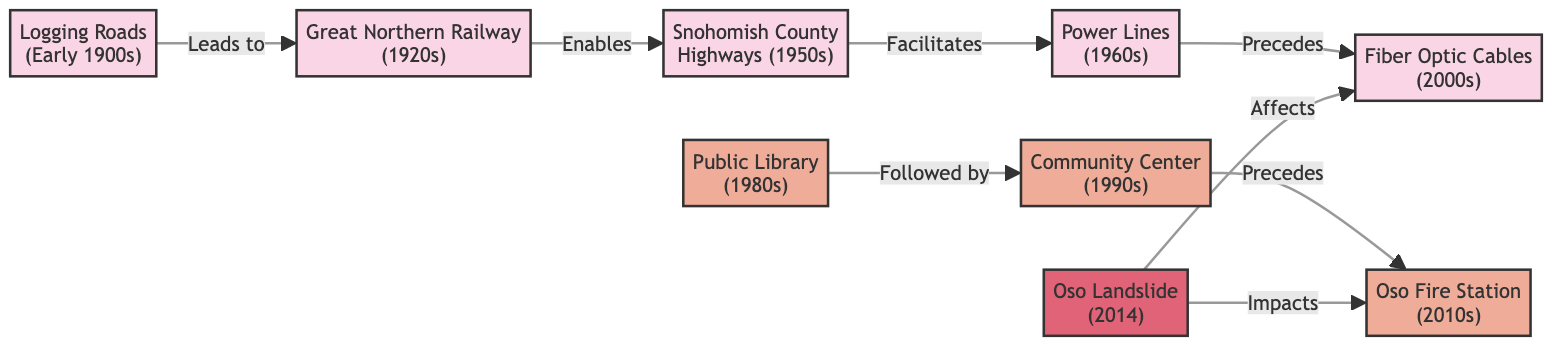What is the most recent infrastructure noted in the diagram? The nodes listed depict various infrastructure developments over time, with "Fiber Optic Cables (2000s)" being the last listed infrastructure node.
Answer: Fiber Optic Cables (2000s) How many nodes are there in total in the diagram? The diagram lists 9 nodes representing infrastructure, community, and an event. Counting these nodes gives a total of 9.
Answer: 9 What event impacts the Oso Fire Station? The relationship indicated in the diagram shows that "Oso Landslide (2014)" impacts the "Oso Fire Station (2010s)", as evidenced by the direct edge connecting them.
Answer: Oso Landslide (2014) Which infrastructure facilitated the development of Power Lines? Looking at the directed path in the diagram, "Snohomish County Highways (1950s)" is directly connected to "Power Lines (1960s)", indicating it facilitated the latter's development.
Answer: Snohomish County Highways (1950s) Which community resource follows the Public Library? The diagram shows an edge connecting "Public Library (1980s)" to "Community Center (1990s)", indicating that the Community Center followed the establishment of the Public Library.
Answer: Community Center (1990s) How many edges connect the infrastructure nodes? By counting the direct paths (edges) established among the infrastructure nodes, there are 4 edges connecting them: from Logging Roads to Great Northern Railway, then to Snohomish County Highways, followed by Power Lines, and finally to Fiber Optic Cables.
Answer: 4 What is the relationship between the Great Northern Railway and Snohomish County Highways? There is an edge that connects "Great Northern Railway (1920s)" to "Snohomish County Highways (1950s)", indicating that the former enables the latter’s development.
Answer: Enables What decade does the Community Center belong to? Through examining the node labeled "Community Center", it is associated with the 1990s, as indicated in the label.
Answer: 1990s How many community nodes exist in the diagram? By identifying the nodes specifically categorized under the community group, we find three nodes—Public Library, Community Center, and Oso Fire Station—which results in a total of 3 community nodes.
Answer: 3 